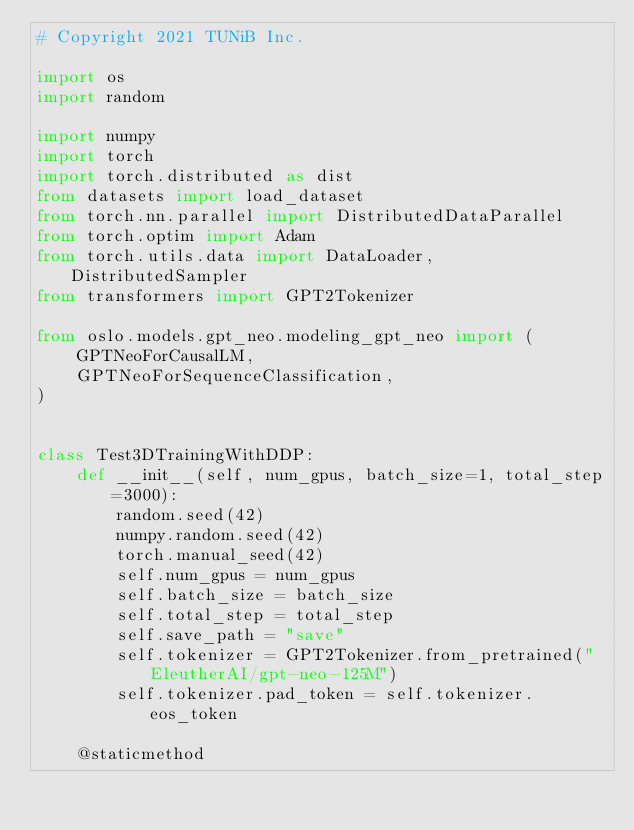Convert code to text. <code><loc_0><loc_0><loc_500><loc_500><_Python_># Copyright 2021 TUNiB Inc.

import os
import random

import numpy
import torch
import torch.distributed as dist
from datasets import load_dataset
from torch.nn.parallel import DistributedDataParallel
from torch.optim import Adam
from torch.utils.data import DataLoader, DistributedSampler
from transformers import GPT2Tokenizer

from oslo.models.gpt_neo.modeling_gpt_neo import (
    GPTNeoForCausalLM,
    GPTNeoForSequenceClassification,
)


class Test3DTrainingWithDDP:
    def __init__(self, num_gpus, batch_size=1, total_step=3000):
        random.seed(42)
        numpy.random.seed(42)
        torch.manual_seed(42)
        self.num_gpus = num_gpus
        self.batch_size = batch_size
        self.total_step = total_step
        self.save_path = "save"
        self.tokenizer = GPT2Tokenizer.from_pretrained("EleutherAI/gpt-neo-125M")
        self.tokenizer.pad_token = self.tokenizer.eos_token

    @staticmethod</code> 